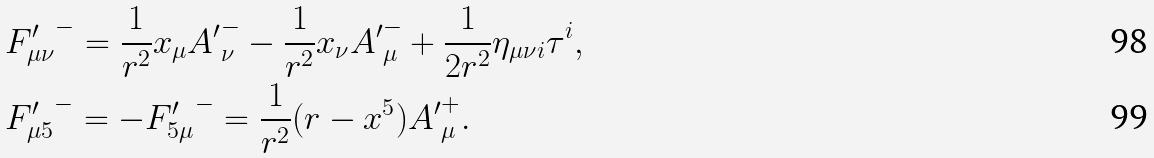<formula> <loc_0><loc_0><loc_500><loc_500>& { F ^ { \prime } _ { \mu \nu } } ^ { - } = \frac { 1 } { r ^ { 2 } } x _ { \mu } { A ^ { \prime } } ^ { - } _ { \nu } - \frac { 1 } { r ^ { 2 } } x _ { \nu } { A ^ { \prime } } ^ { - } _ { \mu } + \frac { 1 } { 2 r ^ { 2 } } \eta _ { \mu \nu i } \tau ^ { i } , \\ & { F ^ { \prime } _ { \mu 5 } } ^ { - } = - { F ^ { \prime } _ { 5 \mu } } ^ { - } = \frac { 1 } { r ^ { 2 } } ( r - x ^ { 5 } ) { A ^ { \prime } } ^ { + } _ { \mu } .</formula> 